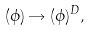<formula> <loc_0><loc_0><loc_500><loc_500>( \phi ) \rightarrow ( \phi ) ^ { D } ,</formula> 